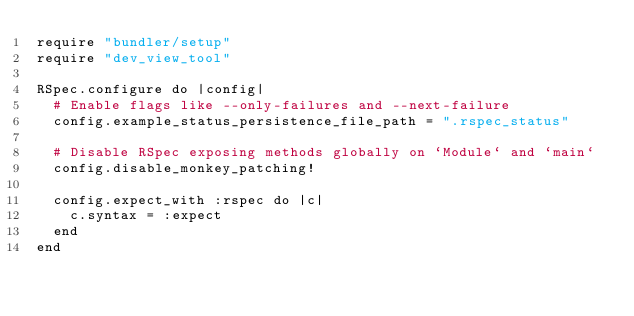Convert code to text. <code><loc_0><loc_0><loc_500><loc_500><_Ruby_>require "bundler/setup"
require "dev_view_tool"

RSpec.configure do |config|
  # Enable flags like --only-failures and --next-failure
  config.example_status_persistence_file_path = ".rspec_status"

  # Disable RSpec exposing methods globally on `Module` and `main`
  config.disable_monkey_patching!

  config.expect_with :rspec do |c|
    c.syntax = :expect
  end
end
</code> 